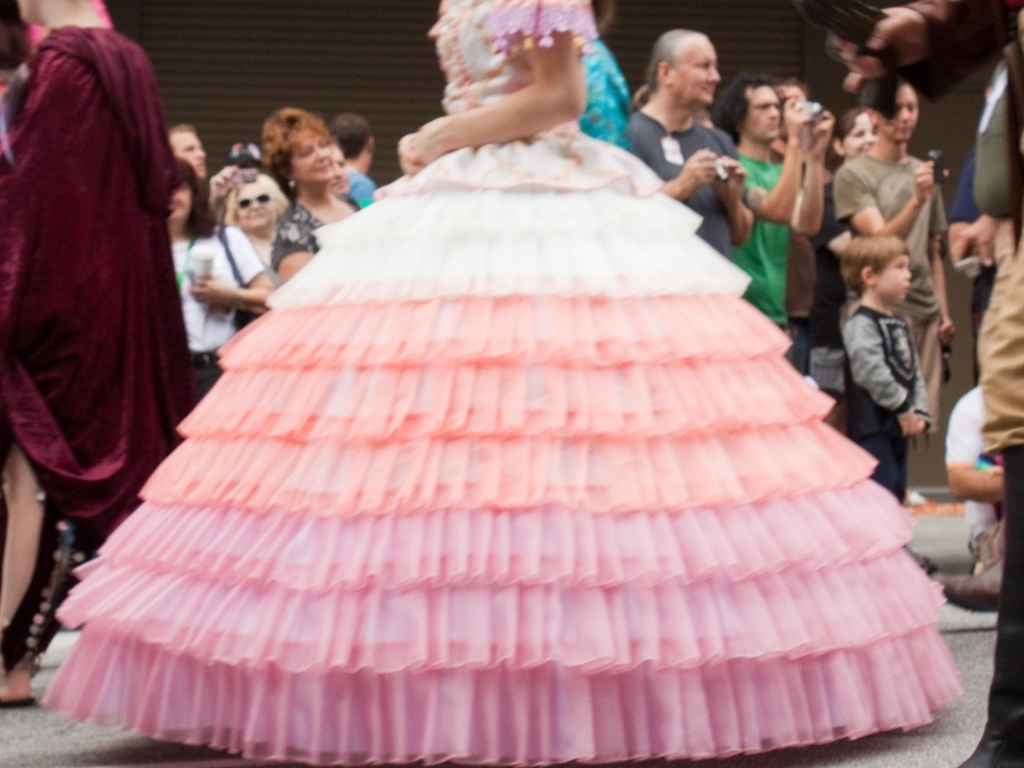Can you describe the event or setting where this photo was taken? This image appears to capture a public gathering, possibly a street event or parade, given the presence of a person in a large, vibrant pink dress, which suggests a festive occasion. The blurred background shows spectators, some taking photos, indicating that this may be a performance or a celebration event drawing public attention. 